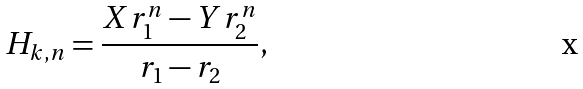<formula> <loc_0><loc_0><loc_500><loc_500>H _ { k , n } = \frac { X r _ { 1 } ^ { n } - Y r _ { 2 } ^ { n } } { r _ { 1 } - r _ { 2 } } ,</formula> 